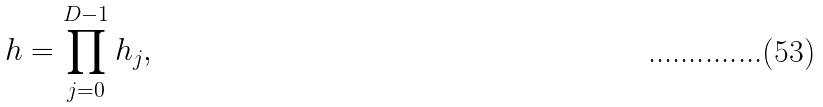Convert formula to latex. <formula><loc_0><loc_0><loc_500><loc_500>h = \prod ^ { D - 1 } _ { j = 0 } h _ { j } ,</formula> 